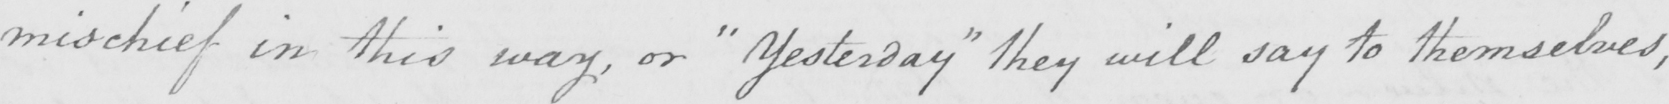What text is written in this handwritten line? mischief in this way , or  " yesterday "  they will say to themselves , 